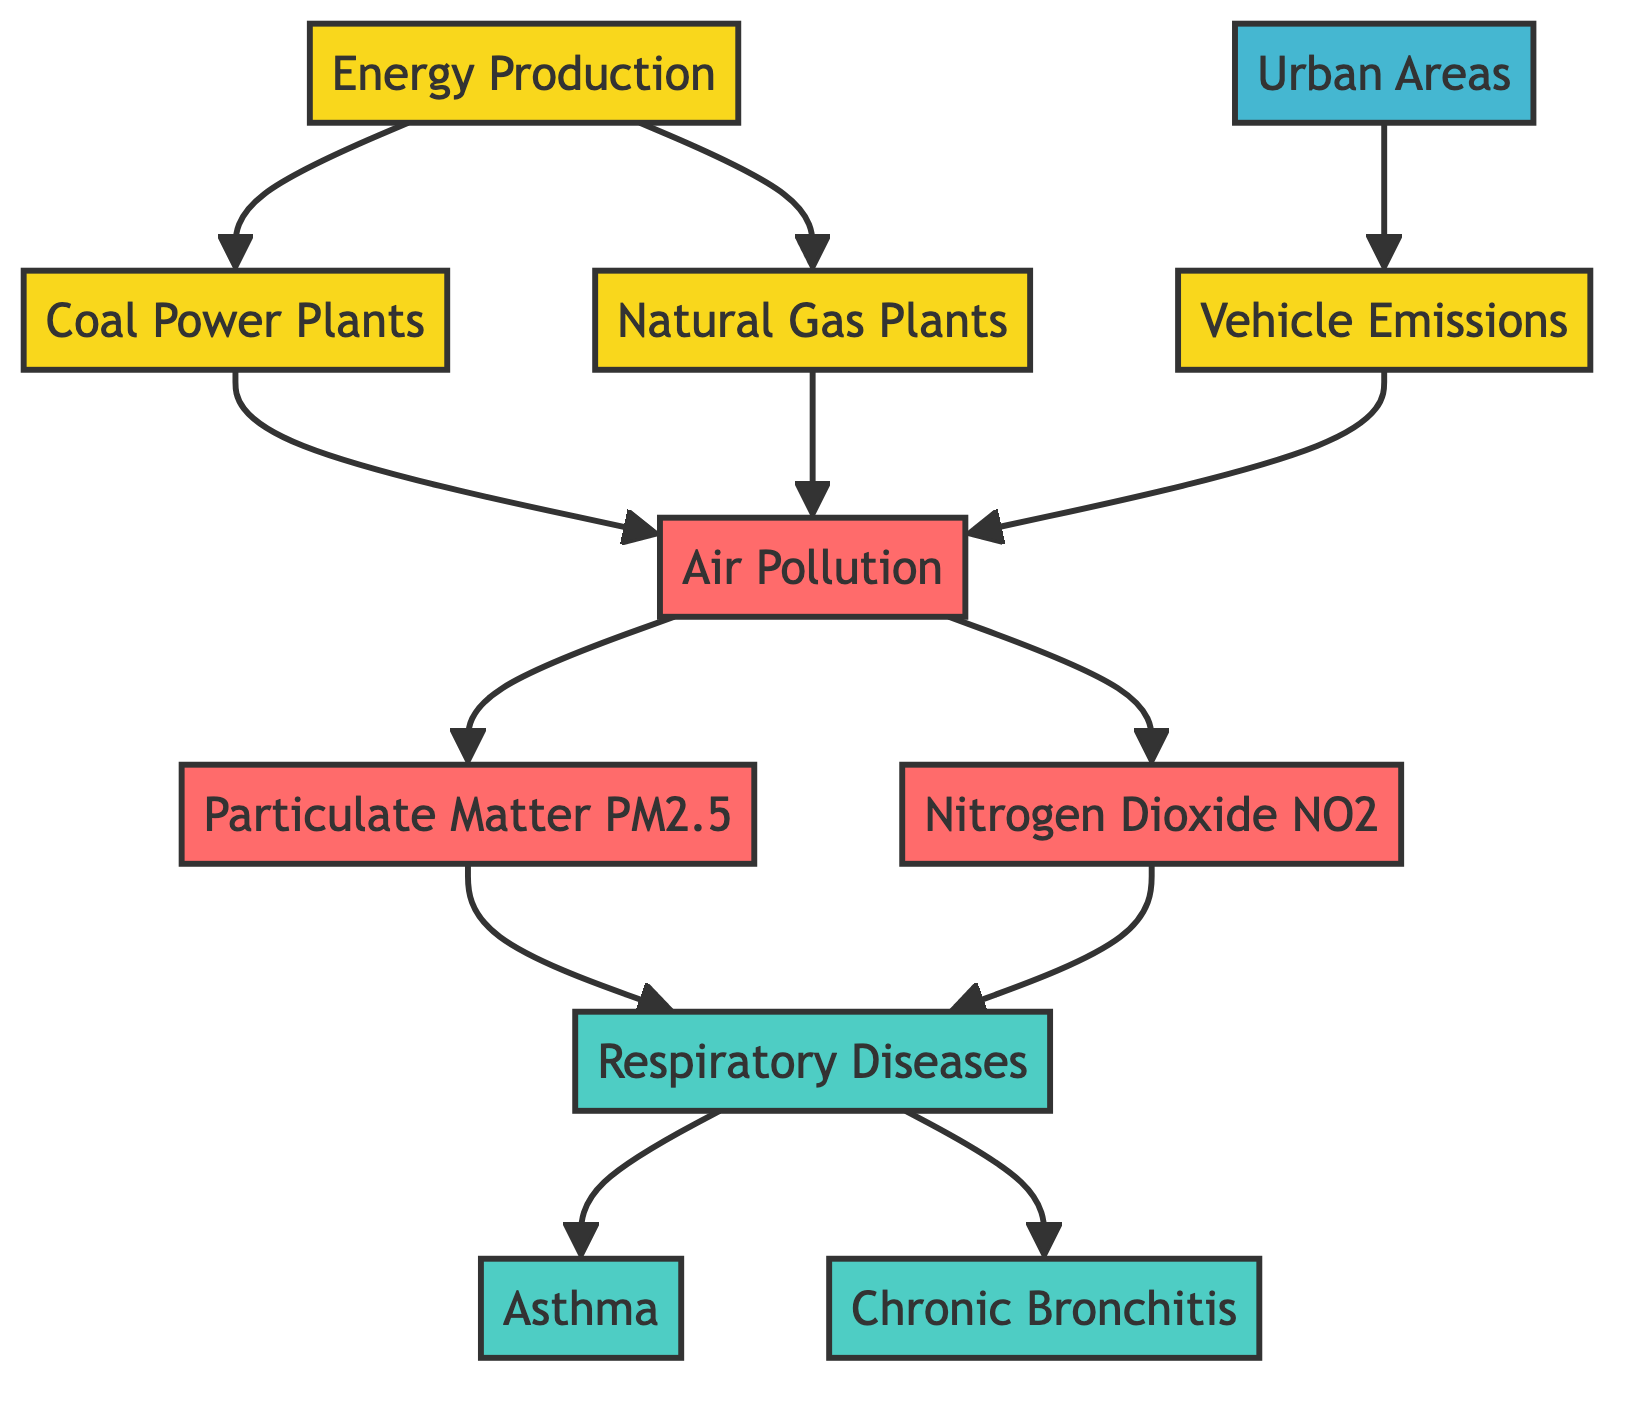What is the primary source of air pollution in the diagram? The diagram indicates that coal power plants and natural gas plants are major contributors to air pollution, both originating from energy production.
Answer: Coal power plants What type of respiratory disease is connected to particulate matter? The diagram shows a direct connection from particulate matter PM2.5 to respiratory diseases, indicating that PM2.5 influences these conditions.
Answer: Respiratory diseases How many types of respiratory diseases are identified in the diagram? By analyzing the nodes, we can count the specific types of respiratory diseases presented: asthma and chronic bronchitis, making a total of two.
Answer: Two Which pollutant is linked to vehicle emissions in urban areas? The flowchart illustrates that vehicle emissions contribute to air pollution, which subsequently leads to the presence of nitrogen dioxide.
Answer: Nitrogen Dioxide What is the relationship between air pollution and respiratory diseases? The diagram establishes that air pollution is a precursor to respiratory diseases, indicating a cause-and-effect relationship.
Answer: Cause-and-effect Which energy production source leads to the highest level of air pollution according to the diagram? The diagram connects energy production to both coal and natural gas plants; however, coal power plants are typically associated with higher levels of pollutants compared to natural gas.
Answer: Coal Power Plants What element represents urban areas in the diagram? The diagram uses "UA" as the node to represent urban areas, indicating where the effects of air pollution and respiratory diseases can be analyzed.
Answer: Urban Areas How many edges connect energy production to air pollution in the diagram? The flowchart shows three edges originating from energy production nodes (coal power plants, natural gas plants) to air pollution, confirming the correlation specified.
Answer: Three 